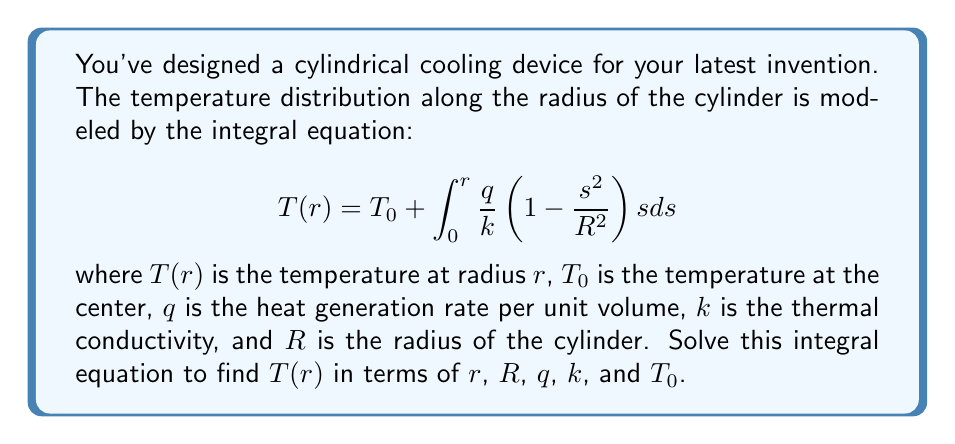Provide a solution to this math problem. Let's solve this integral equation step by step:

1) First, let's focus on the integrand:
   $$\frac{q}{k} \left(1 - \frac{s^2}{R^2}\right) s$$

2) We can rewrite this as:
   $$\frac{q}{k} \left(s - \frac{s^3}{R^2}\right)$$

3) Now, let's integrate this from 0 to r:
   $$\int_0^r \frac{q}{k} \left(s - \frac{s^3}{R^2}\right) ds$$

4) Integrating term by term:
   $$\frac{q}{k} \left[\frac{s^2}{2} - \frac{s^4}{4R^2}\right]_0^r$$

5) Evaluating the integral:
   $$\frac{q}{k} \left(\frac{r^2}{2} - \frac{r^4}{4R^2}\right)$$

6) Adding this to $T_0$ as per the original equation:
   $$T(r) = T_0 + \frac{q}{k} \left(\frac{r^2}{2} - \frac{r^4}{4R^2}\right)$$

7) This can be rearranged to:
   $$T(r) = T_0 + \frac{qr^2}{2k} \left(1 - \frac{r^2}{2R^2}\right)$$

This is the final solution for $T(r)$ in terms of $r$, $R$, $q$, $k$, and $T_0$.
Answer: $T(r) = T_0 + \frac{qr^2}{2k} \left(1 - \frac{r^2}{2R^2}\right)$ 